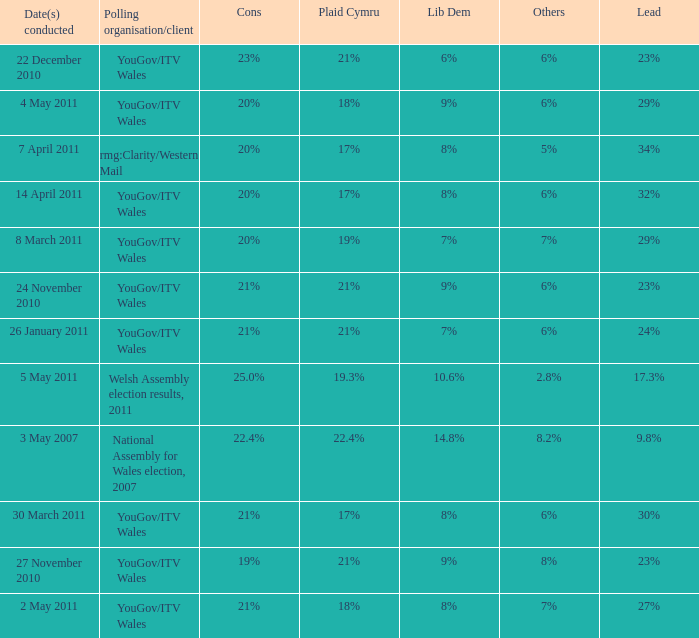I want the lead for others being 5% 34%. 